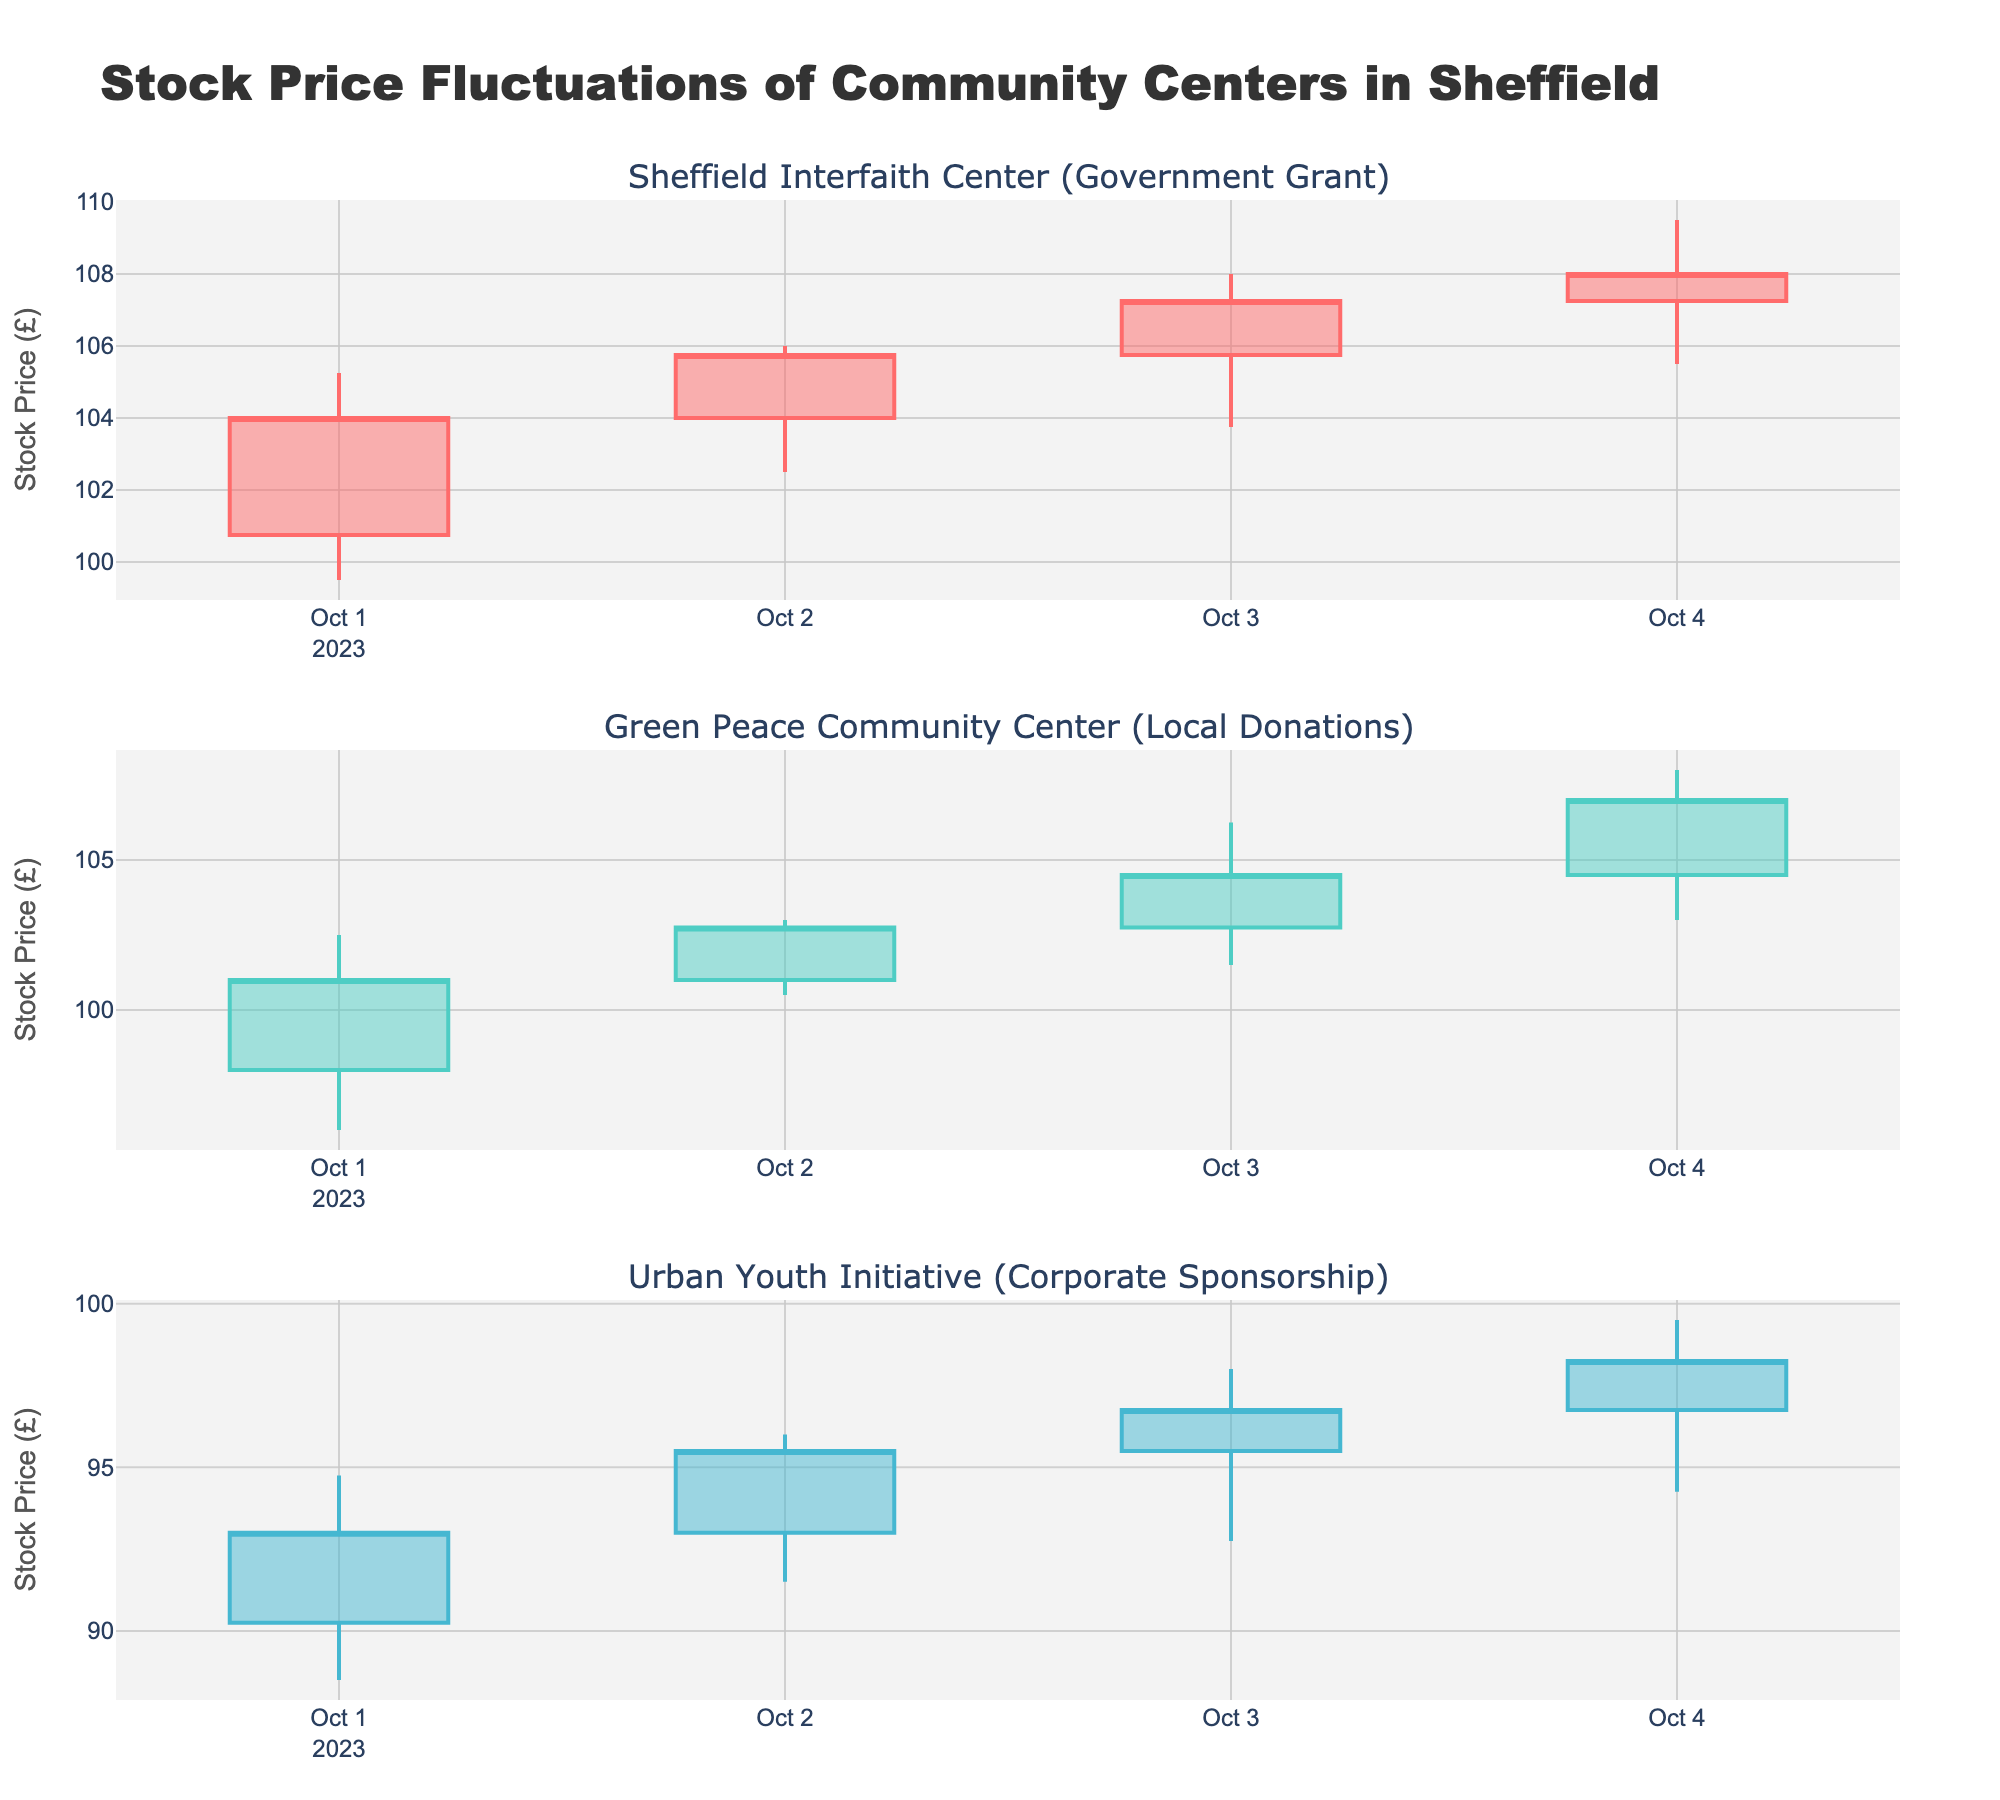What is the title of the figure? The title is usually located at the top of the figure. In this case, the title "Stock Price Fluctuations of Community Centers in Sheffield" is explicitly stated in the layout.
Answer: Stock Price Fluctuations of Community Centers in Sheffield How many community centers are represented in the figure? To determine the number of community centers represented, look at the number of subplot titles; here, there are three subplot titles indicating three centers.
Answer: 3 What is the funding source of the Green Peace Community Center? The funding source is mentioned next to the community center's name in the subplot title. For the Green Peace Community Center, it is specified as "Local Donations."
Answer: Local Donations Between October 1st and 4th, which day had the highest closing price for the Urban Youth Initiative? By examining the candlestick for each day in the Urban Youth Initiative subplot, check the top line of the closing marker. The highest closing price is recorded on October 4th with a value of 98.25.
Answer: October 4th Which community center shows the most significant increase in closing price between October 1st and October 4th? Calculate the increase by subtracting the closing price on October 1st from the closing price on October 4th for each center. The increases are:
- Sheffield Interfaith Center: 108.00 - 104.00 = 4.00
- Green Peace Community Center: 107.00 - 101.00 = 6.00
- Urban Youth Initiative: 98.25 - 93.00 = 5.25 
The Green Peace Community Center shows the most significant increase.
Answer: Green Peace Community Center On October 3rd, which community center had the highest low price? Examine the candlestick representing October 3rd in each subplot and compare the lower edges of the candlesticks. The highest low price on October 3rd is found in the Sheffield Interfaith Center with a value of 103.75.
Answer: Sheffield Interfaith Center What is the range of stock prices (difference between high and low) for the Sheffield Interfaith Center on October 2nd? Subtract the low price from the high price on October 2nd: 106.00 - 102.50 = 3.50
Answer: 3.50 How did the closing prices for Green Peace Community Center change from October 1st to October 2nd? Compare the closing prices on October 1st and October 2nd for Green Peace Community Center. The values are 101.00 and 102.75, respectively. The change is 102.75 - 101.00 = 1.75, indicating an increase.
Answer: Increased by 1.75 